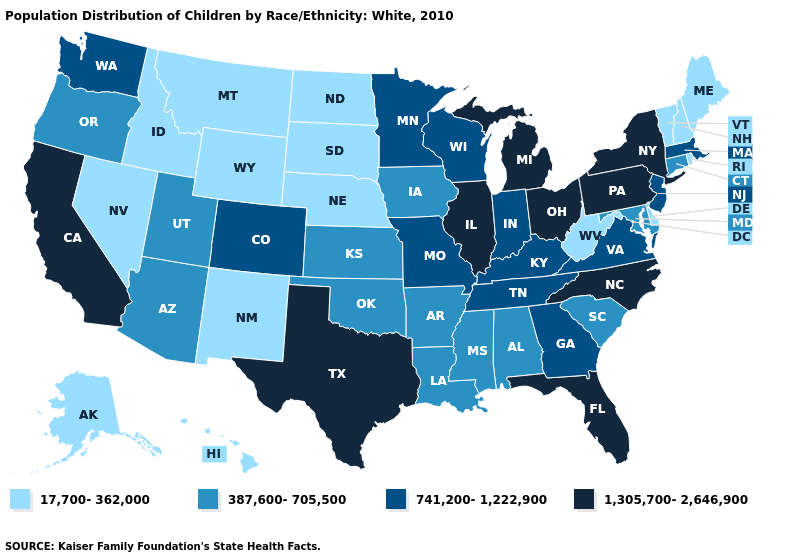Which states have the lowest value in the West?
Be succinct. Alaska, Hawaii, Idaho, Montana, Nevada, New Mexico, Wyoming. What is the value of Michigan?
Be succinct. 1,305,700-2,646,900. Which states have the lowest value in the MidWest?
Concise answer only. Nebraska, North Dakota, South Dakota. Name the states that have a value in the range 387,600-705,500?
Answer briefly. Alabama, Arizona, Arkansas, Connecticut, Iowa, Kansas, Louisiana, Maryland, Mississippi, Oklahoma, Oregon, South Carolina, Utah. Name the states that have a value in the range 1,305,700-2,646,900?
Give a very brief answer. California, Florida, Illinois, Michigan, New York, North Carolina, Ohio, Pennsylvania, Texas. Among the states that border Alabama , which have the lowest value?
Short answer required. Mississippi. Name the states that have a value in the range 1,305,700-2,646,900?
Concise answer only. California, Florida, Illinois, Michigan, New York, North Carolina, Ohio, Pennsylvania, Texas. Among the states that border Wisconsin , which have the lowest value?
Give a very brief answer. Iowa. What is the value of Oregon?
Write a very short answer. 387,600-705,500. Name the states that have a value in the range 1,305,700-2,646,900?
Write a very short answer. California, Florida, Illinois, Michigan, New York, North Carolina, Ohio, Pennsylvania, Texas. What is the value of Indiana?
Write a very short answer. 741,200-1,222,900. Name the states that have a value in the range 17,700-362,000?
Quick response, please. Alaska, Delaware, Hawaii, Idaho, Maine, Montana, Nebraska, Nevada, New Hampshire, New Mexico, North Dakota, Rhode Island, South Dakota, Vermont, West Virginia, Wyoming. Name the states that have a value in the range 387,600-705,500?
Concise answer only. Alabama, Arizona, Arkansas, Connecticut, Iowa, Kansas, Louisiana, Maryland, Mississippi, Oklahoma, Oregon, South Carolina, Utah. Does the first symbol in the legend represent the smallest category?
Concise answer only. Yes. 